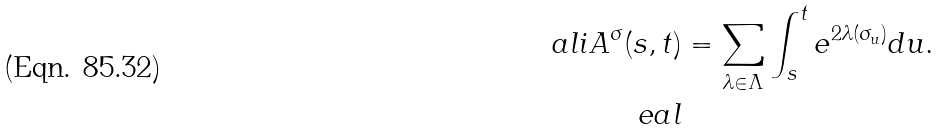<formula> <loc_0><loc_0><loc_500><loc_500>\ a l i A ^ { \sigma } ( s , t ) & = \sum _ { \lambda \in \Lambda } \int _ { s } ^ { t } e ^ { 2 \lambda ( \sigma _ { u } ) } d u . \\ \ e a l</formula> 